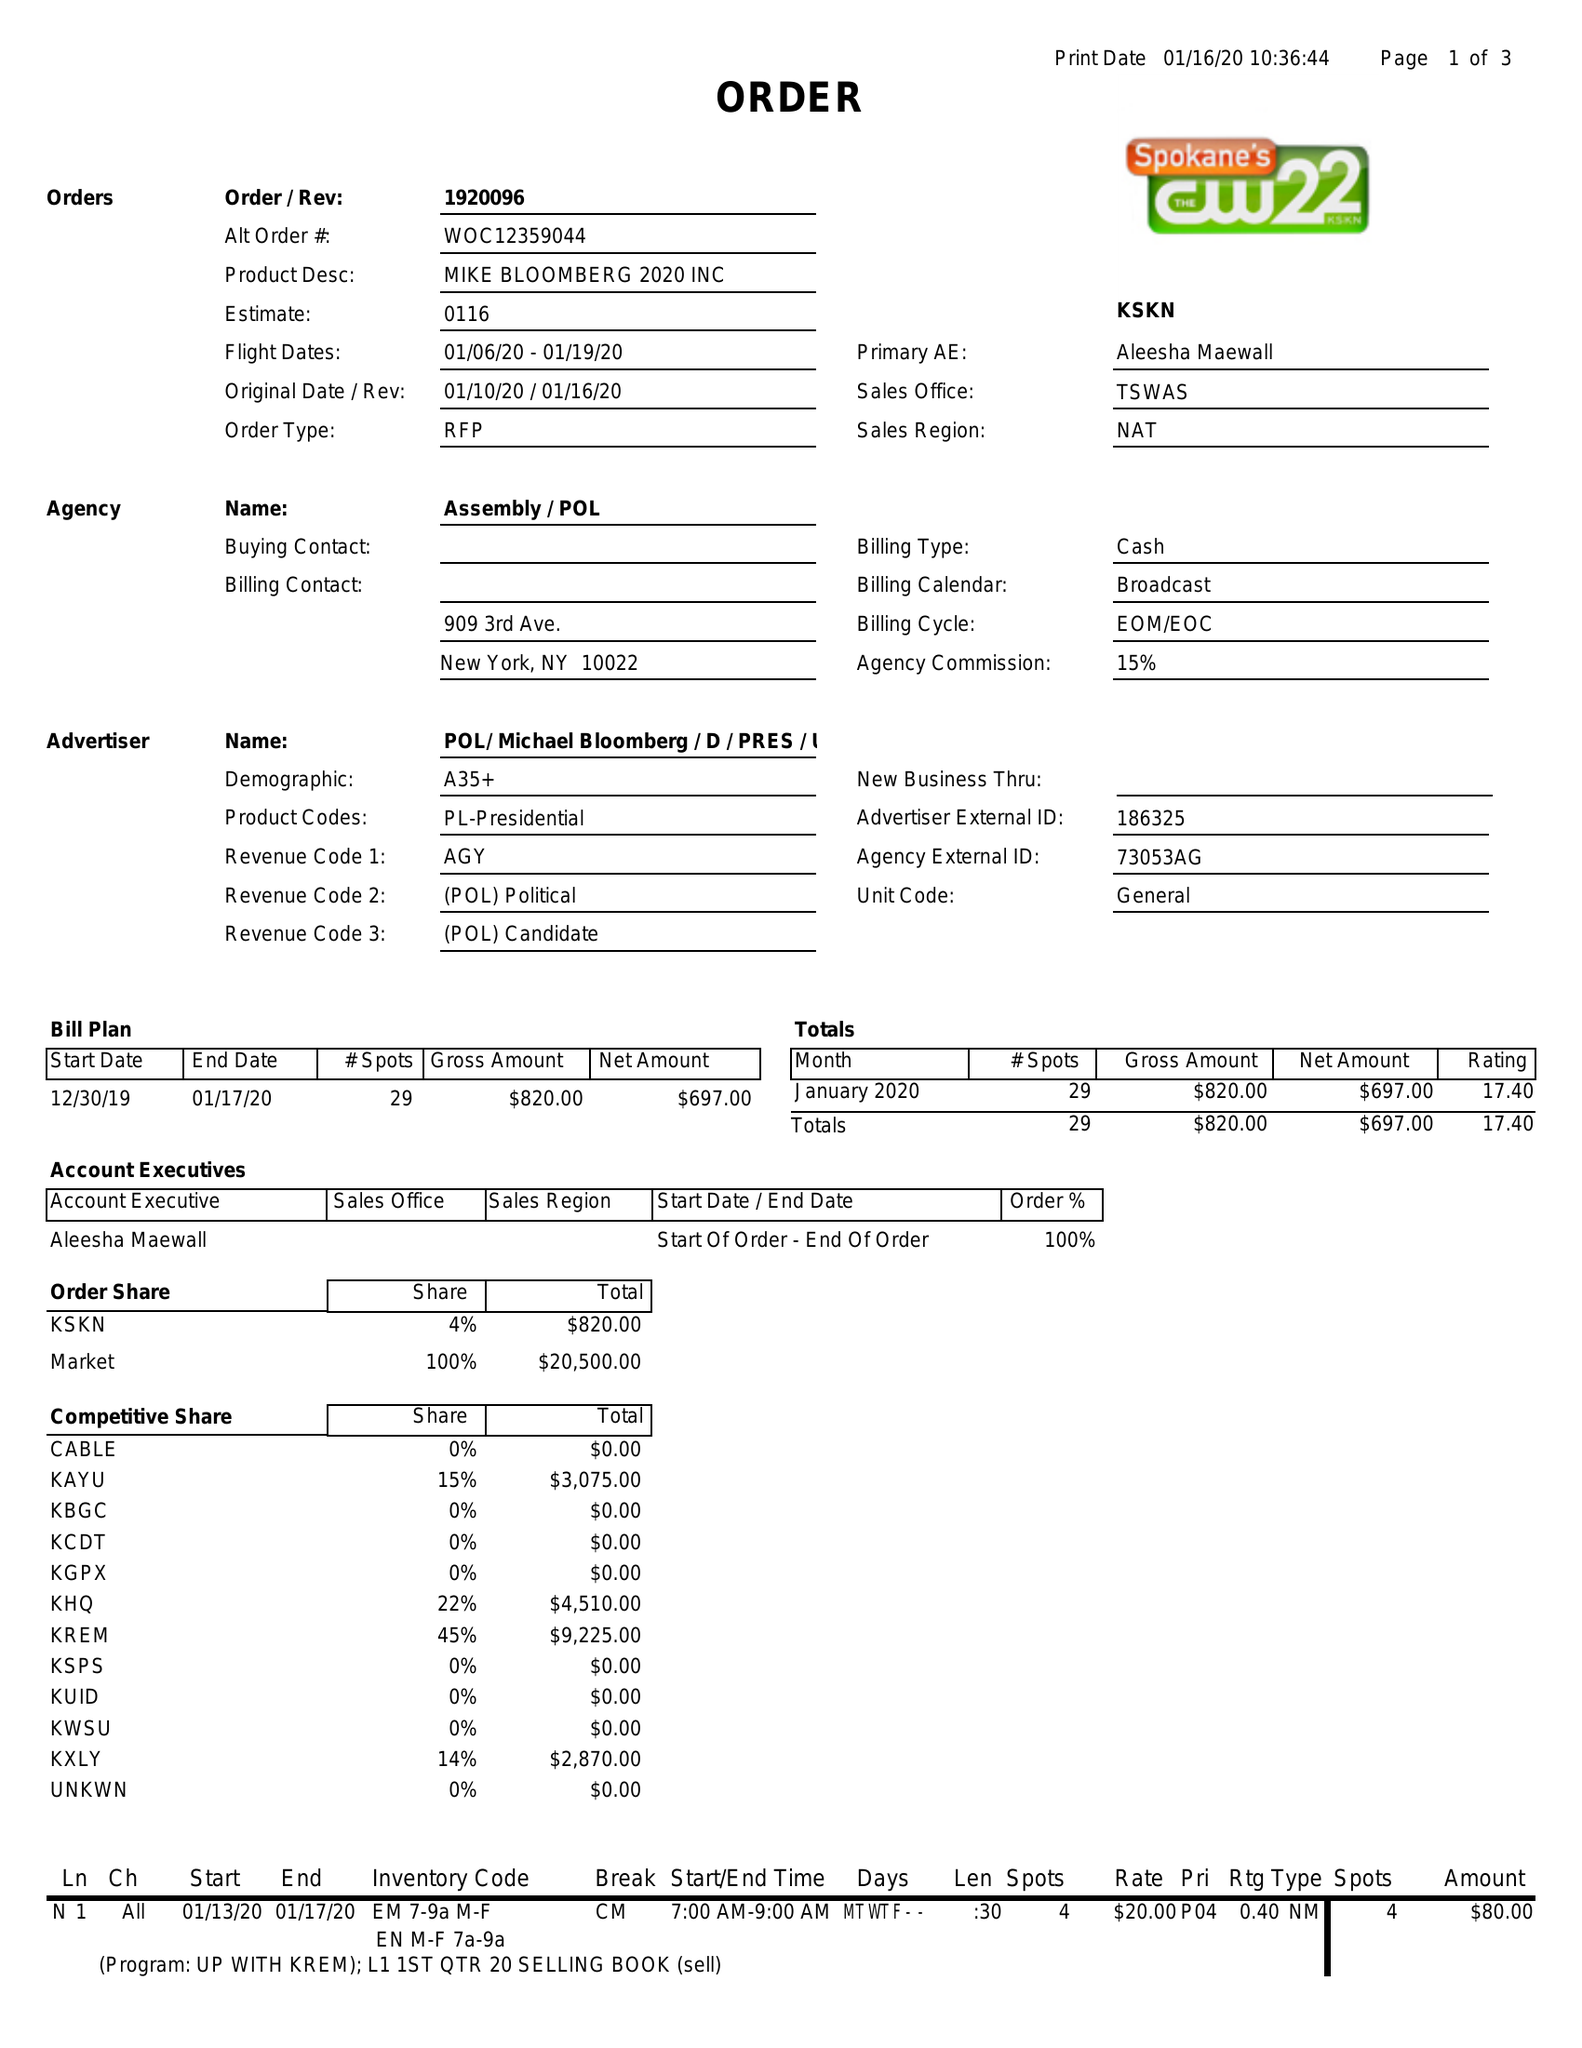What is the value for the flight_to?
Answer the question using a single word or phrase. 01/19/20 